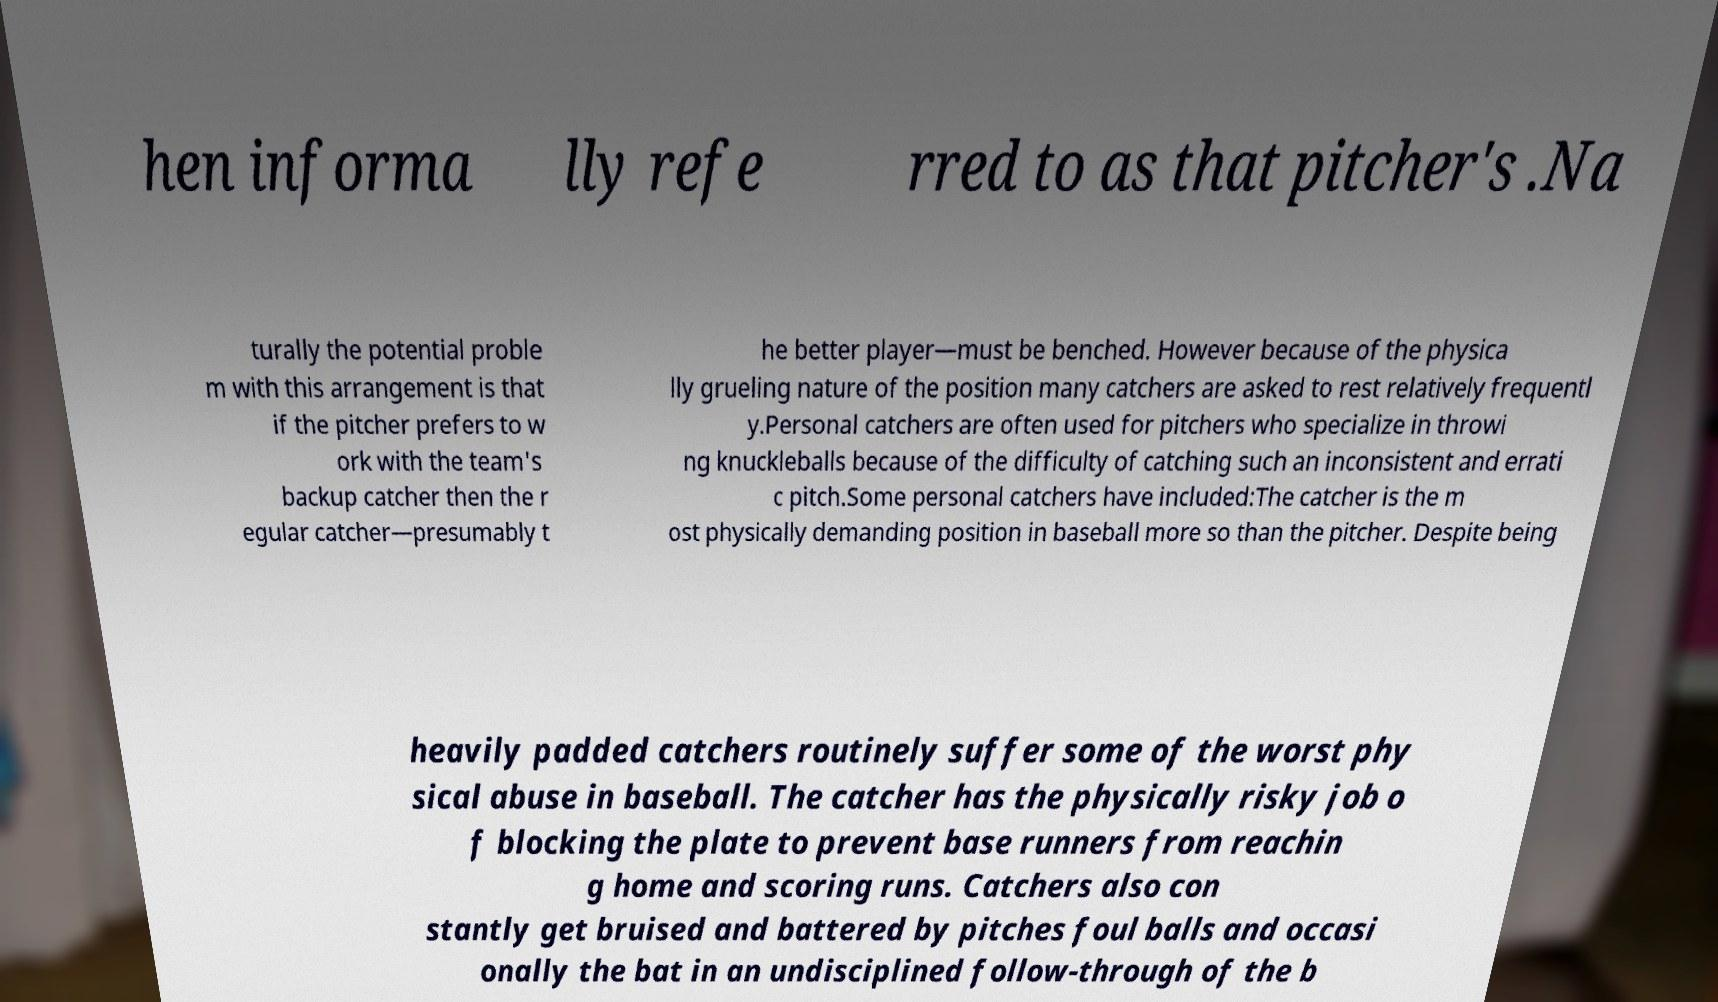Can you read and provide the text displayed in the image?This photo seems to have some interesting text. Can you extract and type it out for me? hen informa lly refe rred to as that pitcher's .Na turally the potential proble m with this arrangement is that if the pitcher prefers to w ork with the team's backup catcher then the r egular catcher—presumably t he better player—must be benched. However because of the physica lly grueling nature of the position many catchers are asked to rest relatively frequentl y.Personal catchers are often used for pitchers who specialize in throwi ng knuckleballs because of the difficulty of catching such an inconsistent and errati c pitch.Some personal catchers have included:The catcher is the m ost physically demanding position in baseball more so than the pitcher. Despite being heavily padded catchers routinely suffer some of the worst phy sical abuse in baseball. The catcher has the physically risky job o f blocking the plate to prevent base runners from reachin g home and scoring runs. Catchers also con stantly get bruised and battered by pitches foul balls and occasi onally the bat in an undisciplined follow-through of the b 